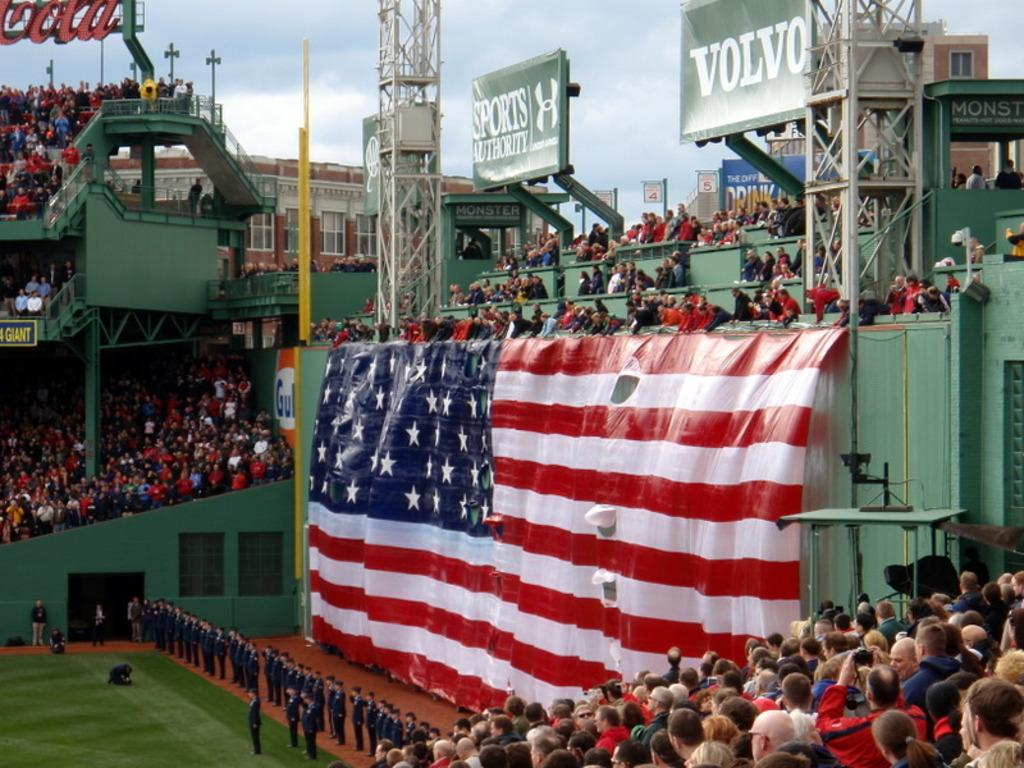<image>
Summarize the visual content of the image. A large American flag hanging off the side of a stadium with an ad above from Volvo and the stadium is filled 